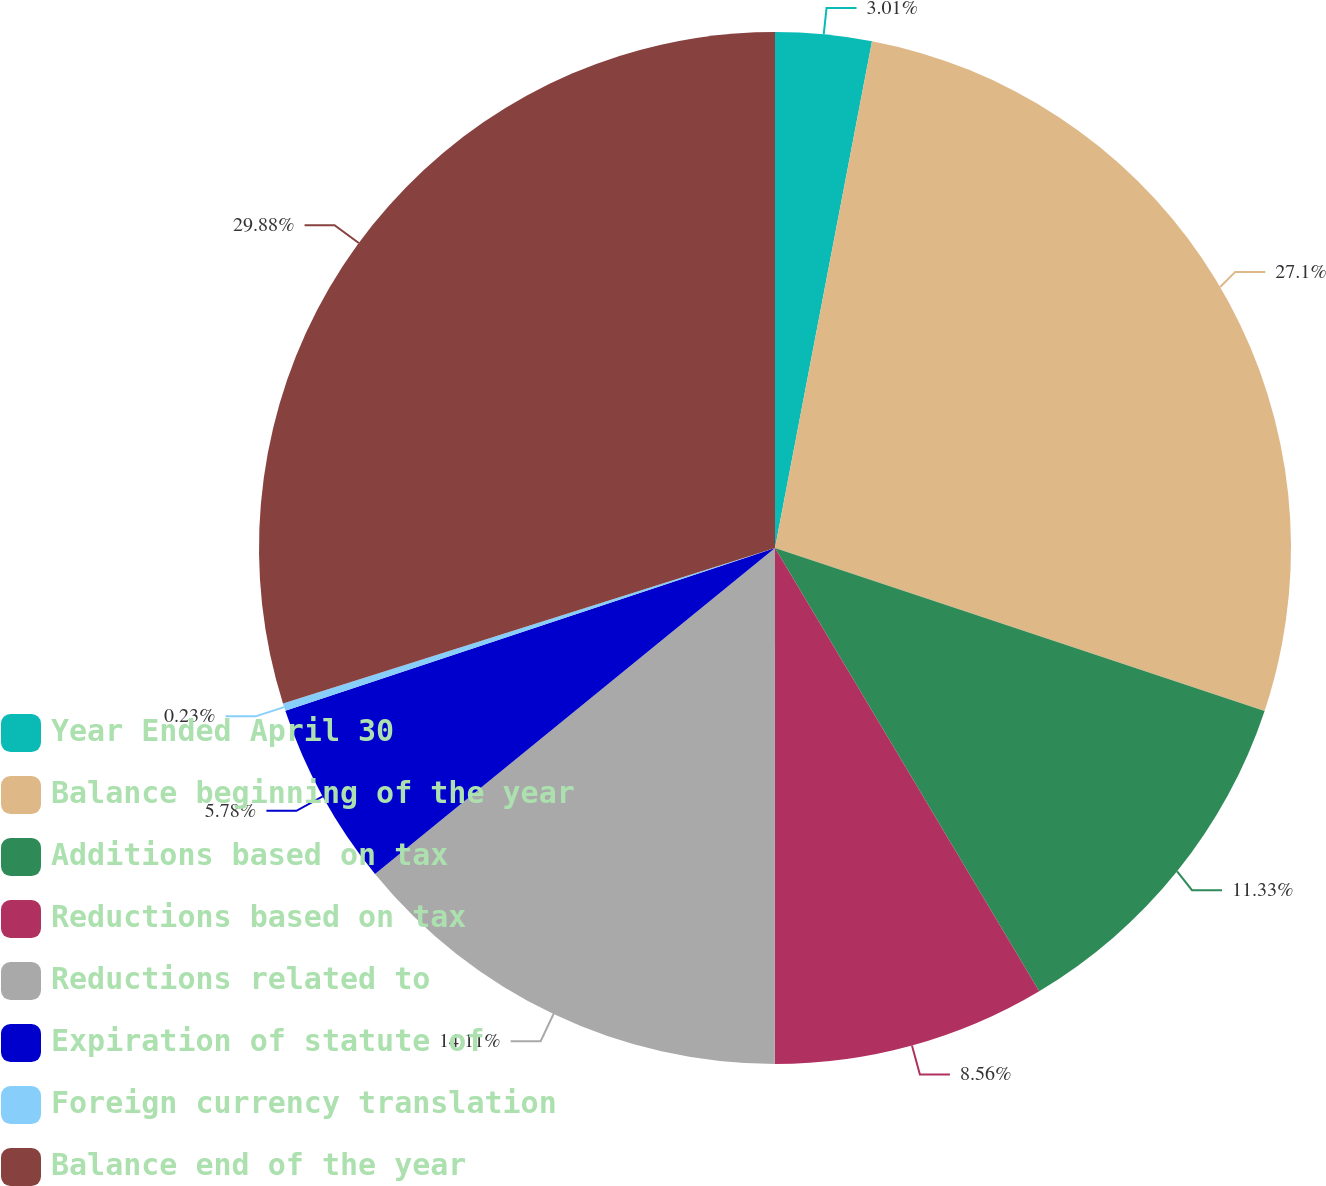Convert chart. <chart><loc_0><loc_0><loc_500><loc_500><pie_chart><fcel>Year Ended April 30<fcel>Balance beginning of the year<fcel>Additions based on tax<fcel>Reductions based on tax<fcel>Reductions related to<fcel>Expiration of statute of<fcel>Foreign currency translation<fcel>Balance end of the year<nl><fcel>3.01%<fcel>27.1%<fcel>11.33%<fcel>8.56%<fcel>14.11%<fcel>5.78%<fcel>0.23%<fcel>29.87%<nl></chart> 